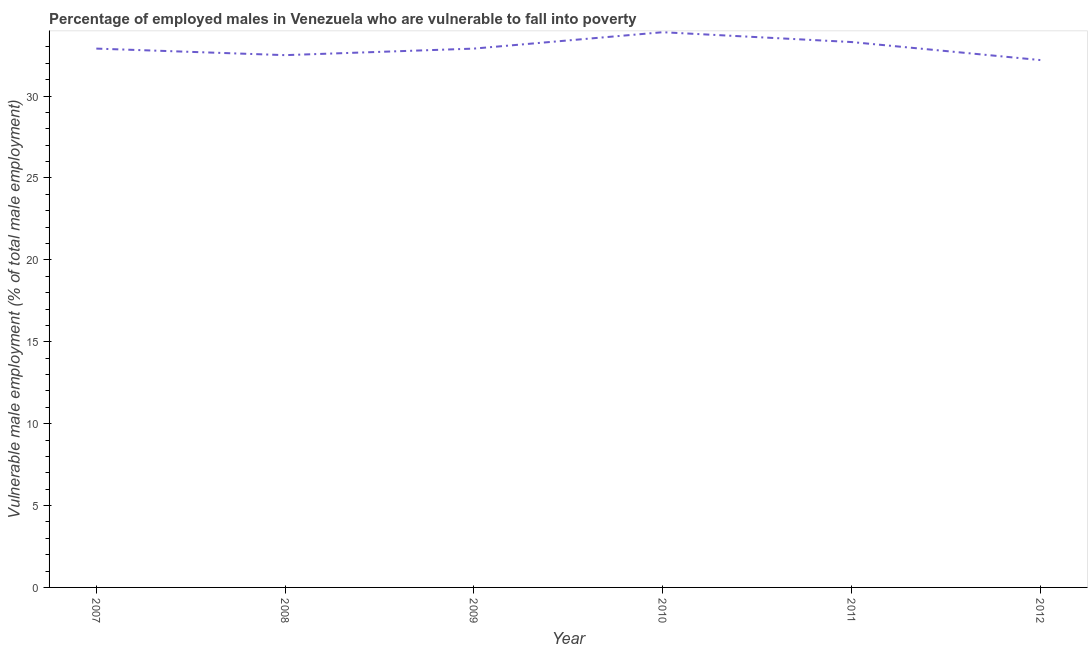What is the percentage of employed males who are vulnerable to fall into poverty in 2008?
Your answer should be compact. 32.5. Across all years, what is the maximum percentage of employed males who are vulnerable to fall into poverty?
Make the answer very short. 33.9. Across all years, what is the minimum percentage of employed males who are vulnerable to fall into poverty?
Your answer should be very brief. 32.2. In which year was the percentage of employed males who are vulnerable to fall into poverty maximum?
Ensure brevity in your answer.  2010. In which year was the percentage of employed males who are vulnerable to fall into poverty minimum?
Offer a very short reply. 2012. What is the sum of the percentage of employed males who are vulnerable to fall into poverty?
Make the answer very short. 197.7. What is the difference between the percentage of employed males who are vulnerable to fall into poverty in 2008 and 2009?
Your response must be concise. -0.4. What is the average percentage of employed males who are vulnerable to fall into poverty per year?
Give a very brief answer. 32.95. What is the median percentage of employed males who are vulnerable to fall into poverty?
Give a very brief answer. 32.9. What is the ratio of the percentage of employed males who are vulnerable to fall into poverty in 2007 to that in 2011?
Ensure brevity in your answer.  0.99. Is the percentage of employed males who are vulnerable to fall into poverty in 2007 less than that in 2009?
Offer a very short reply. No. Is the difference between the percentage of employed males who are vulnerable to fall into poverty in 2008 and 2009 greater than the difference between any two years?
Offer a very short reply. No. What is the difference between the highest and the second highest percentage of employed males who are vulnerable to fall into poverty?
Provide a short and direct response. 0.6. Is the sum of the percentage of employed males who are vulnerable to fall into poverty in 2009 and 2012 greater than the maximum percentage of employed males who are vulnerable to fall into poverty across all years?
Ensure brevity in your answer.  Yes. What is the difference between the highest and the lowest percentage of employed males who are vulnerable to fall into poverty?
Ensure brevity in your answer.  1.7. In how many years, is the percentage of employed males who are vulnerable to fall into poverty greater than the average percentage of employed males who are vulnerable to fall into poverty taken over all years?
Your answer should be very brief. 2. How many lines are there?
Your answer should be compact. 1. How many years are there in the graph?
Your answer should be compact. 6. What is the difference between two consecutive major ticks on the Y-axis?
Your answer should be compact. 5. Are the values on the major ticks of Y-axis written in scientific E-notation?
Make the answer very short. No. What is the title of the graph?
Provide a succinct answer. Percentage of employed males in Venezuela who are vulnerable to fall into poverty. What is the label or title of the X-axis?
Your response must be concise. Year. What is the label or title of the Y-axis?
Make the answer very short. Vulnerable male employment (% of total male employment). What is the Vulnerable male employment (% of total male employment) in 2007?
Provide a short and direct response. 32.9. What is the Vulnerable male employment (% of total male employment) in 2008?
Ensure brevity in your answer.  32.5. What is the Vulnerable male employment (% of total male employment) in 2009?
Give a very brief answer. 32.9. What is the Vulnerable male employment (% of total male employment) of 2010?
Ensure brevity in your answer.  33.9. What is the Vulnerable male employment (% of total male employment) of 2011?
Your answer should be compact. 33.3. What is the Vulnerable male employment (% of total male employment) in 2012?
Ensure brevity in your answer.  32.2. What is the difference between the Vulnerable male employment (% of total male employment) in 2007 and 2008?
Offer a terse response. 0.4. What is the difference between the Vulnerable male employment (% of total male employment) in 2007 and 2009?
Provide a short and direct response. 0. What is the difference between the Vulnerable male employment (% of total male employment) in 2007 and 2010?
Give a very brief answer. -1. What is the difference between the Vulnerable male employment (% of total male employment) in 2007 and 2011?
Offer a very short reply. -0.4. What is the difference between the Vulnerable male employment (% of total male employment) in 2007 and 2012?
Provide a short and direct response. 0.7. What is the difference between the Vulnerable male employment (% of total male employment) in 2008 and 2009?
Offer a very short reply. -0.4. What is the difference between the Vulnerable male employment (% of total male employment) in 2009 and 2010?
Provide a succinct answer. -1. What is the difference between the Vulnerable male employment (% of total male employment) in 2010 and 2012?
Your response must be concise. 1.7. What is the ratio of the Vulnerable male employment (% of total male employment) in 2007 to that in 2008?
Provide a short and direct response. 1.01. What is the ratio of the Vulnerable male employment (% of total male employment) in 2007 to that in 2009?
Offer a very short reply. 1. What is the ratio of the Vulnerable male employment (% of total male employment) in 2007 to that in 2011?
Your answer should be very brief. 0.99. What is the ratio of the Vulnerable male employment (% of total male employment) in 2008 to that in 2010?
Provide a succinct answer. 0.96. What is the ratio of the Vulnerable male employment (% of total male employment) in 2009 to that in 2010?
Provide a succinct answer. 0.97. What is the ratio of the Vulnerable male employment (% of total male employment) in 2009 to that in 2011?
Give a very brief answer. 0.99. What is the ratio of the Vulnerable male employment (% of total male employment) in 2010 to that in 2011?
Provide a short and direct response. 1.02. What is the ratio of the Vulnerable male employment (% of total male employment) in 2010 to that in 2012?
Offer a terse response. 1.05. What is the ratio of the Vulnerable male employment (% of total male employment) in 2011 to that in 2012?
Ensure brevity in your answer.  1.03. 